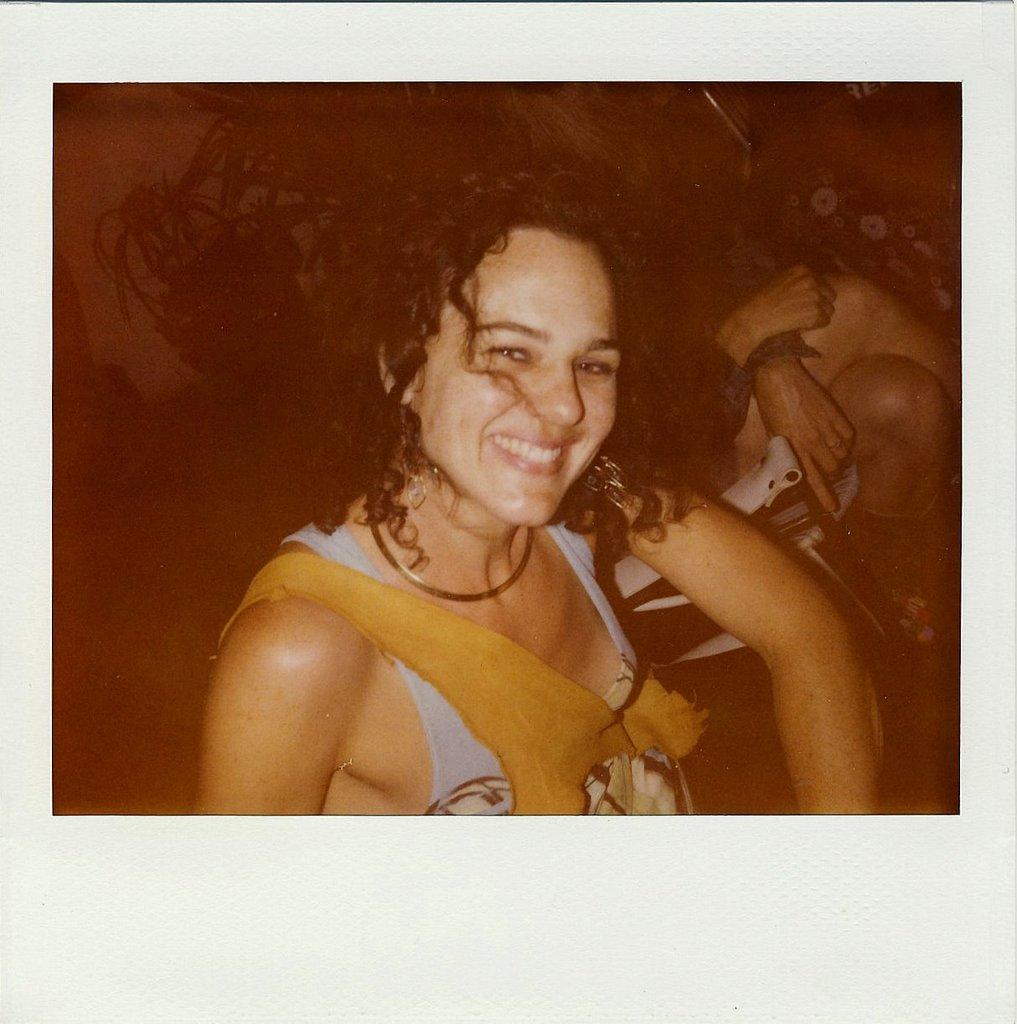What is the person in the image doing? The person is sitting in the image. What expression does the person have? The person is smiling. How would you describe the background of the image? The background of the image is dark. Can you describe the other person in the image? There is another person sitting on a chair in the background. What can be seen in the background besides the person? Flower pots are present in the background. What rhythm is the person tapping their toes to in the image? There is no indication in the image that the person is tapping their toes or following any rhythm. 